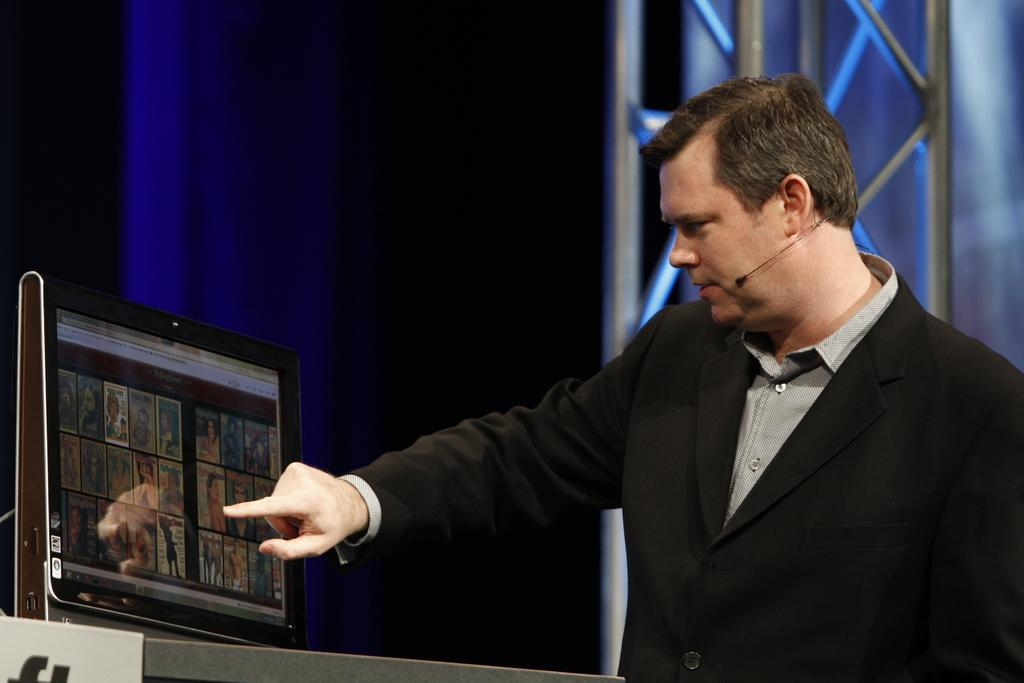What is the main piece of furniture in the image? There is a table in the image. What is placed on the table? There is a monitor on the table. Can you describe the background of the image? There is a person standing in the background, and there is a curtain with poles associated with it. What type of flower is being sold at the market in the image? There is no market or flower present in the image. Can you tell me the name of the guide standing next to the person in the image? There is no guide present in the image; only a person standing in the background. 